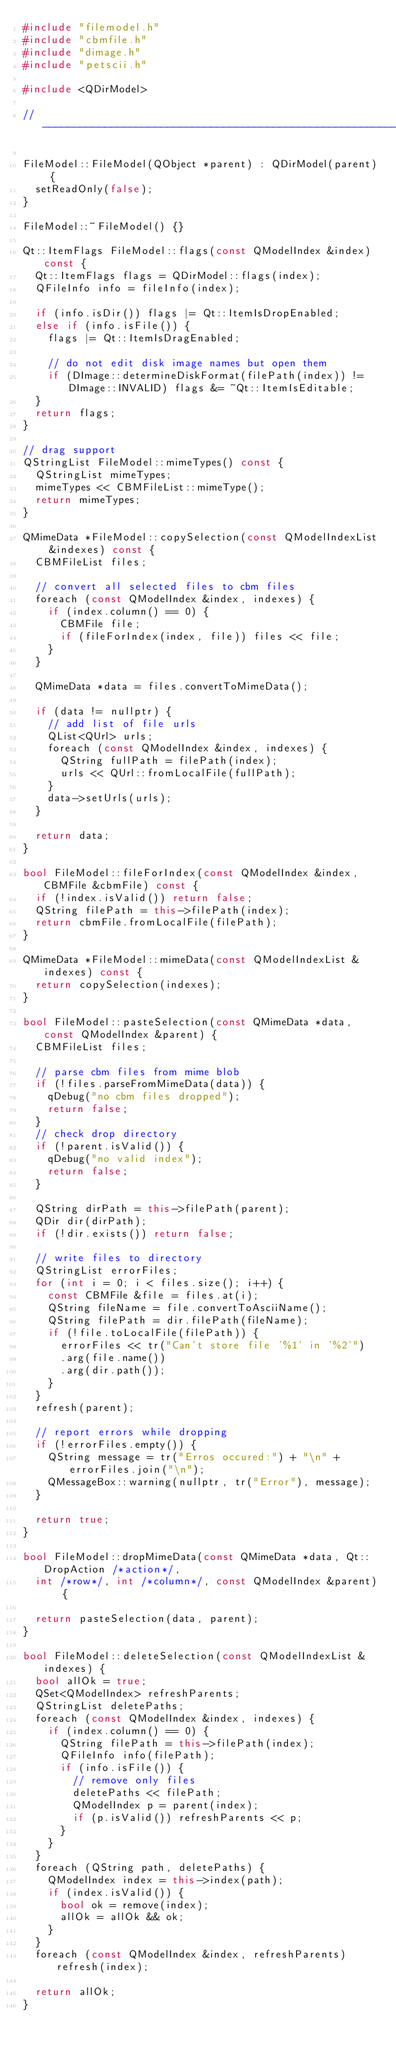<code> <loc_0><loc_0><loc_500><loc_500><_C++_>#include "filemodel.h"
#include "cbmfile.h"
#include "dimage.h"
#include "petscii.h"

#include <QDirModel>

//------------------------------------------------------------------------------

FileModel::FileModel(QObject *parent) : QDirModel(parent) {
	setReadOnly(false);
}

FileModel::~FileModel() {}

Qt::ItemFlags FileModel::flags(const QModelIndex &index) const {
	Qt::ItemFlags flags = QDirModel::flags(index);
	QFileInfo info = fileInfo(index);

	if (info.isDir()) flags |= Qt::ItemIsDropEnabled;
	else if (info.isFile()) {
		flags |= Qt::ItemIsDragEnabled;

		// do not edit disk image names but open them
		if (DImage::determineDiskFormat(filePath(index)) != DImage::INVALID) flags &= ~Qt::ItemIsEditable;
	}
	return flags;
}

// drag support
QStringList FileModel::mimeTypes() const {
	QStringList mimeTypes;
	mimeTypes << CBMFileList::mimeType();
	return mimeTypes;
}

QMimeData *FileModel::copySelection(const QModelIndexList &indexes) const {
	CBMFileList files;

	// convert all selected files to cbm files
	foreach (const QModelIndex &index, indexes) {
		if (index.column() == 0) {
			CBMFile file;
			if (fileForIndex(index, file)) files << file;
		}
	}

	QMimeData *data = files.convertToMimeData();

	if (data != nullptr) {
		// add list of file urls
		QList<QUrl> urls;
		foreach (const QModelIndex &index, indexes) {
			QString fullPath = filePath(index);
			urls << QUrl::fromLocalFile(fullPath);
		}
		data->setUrls(urls);
	}

	return data;
}

bool FileModel::fileForIndex(const QModelIndex &index, CBMFile &cbmFile) const {
	if (!index.isValid()) return false;
	QString filePath = this->filePath(index);
	return cbmFile.fromLocalFile(filePath);
}

QMimeData *FileModel::mimeData(const QModelIndexList &indexes) const {
	return copySelection(indexes);
}

bool FileModel::pasteSelection(const QMimeData *data, const QModelIndex &parent) {
	CBMFileList files;

	// parse cbm files from mime blob
	if (!files.parseFromMimeData(data)) {
		qDebug("no cbm files dropped");
		return false;
	}
	// check drop directory
	if (!parent.isValid()) {
		qDebug("no valid index");
		return false;
	}

	QString dirPath = this->filePath(parent);
	QDir dir(dirPath);
	if (!dir.exists()) return false;

	// write files to directory
	QStringList errorFiles;
	for (int i = 0; i < files.size(); i++) {
		const CBMFile &file = files.at(i);
		QString fileName = file.convertToAsciiName();
		QString filePath = dir.filePath(fileName);
		if (!file.toLocalFile(filePath)) {
			errorFiles << tr("Can't store file '%1' in '%2'")
			.arg(file.name())
			.arg(dir.path());
		}
	}
	refresh(parent);

	// report errors while dropping
	if (!errorFiles.empty()) {
		QString message = tr("Erros occured:") + "\n" + errorFiles.join("\n");
		QMessageBox::warning(nullptr, tr("Error"), message);
	}

	return true;
}

bool FileModel::dropMimeData(const QMimeData *data, Qt::DropAction /*action*/,
	int /*row*/, int /*column*/, const QModelIndex &parent) {

	return pasteSelection(data, parent);
}

bool FileModel::deleteSelection(const QModelIndexList &indexes) {
	bool allOk = true;
	QSet<QModelIndex> refreshParents;
	QStringList deletePaths;
	foreach (const QModelIndex &index, indexes) {
		if (index.column() == 0) {
			QString filePath = this->filePath(index);
			QFileInfo info(filePath);
			if (info.isFile()) {
				// remove only files
				deletePaths << filePath;
				QModelIndex p = parent(index);
				if (p.isValid()) refreshParents << p;
			}
		}
	}
	foreach (QString path, deletePaths) {
		QModelIndex index = this->index(path);
		if (index.isValid()) {
			bool ok = remove(index);
			allOk = allOk && ok;
		}
	}
	foreach (const QModelIndex &index, refreshParents) refresh(index);

	return allOk;
}
</code> 